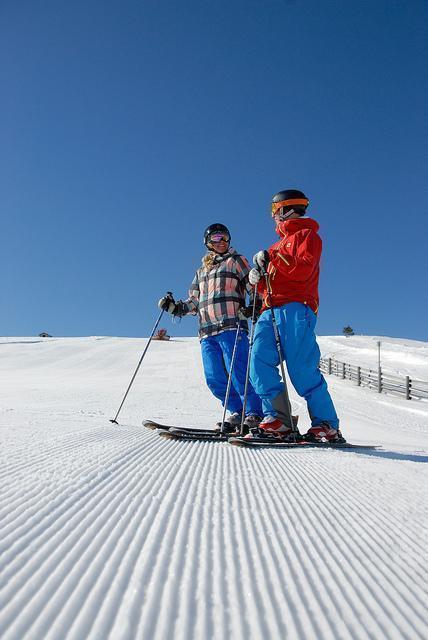Why are they so close together?
Answer the question by selecting the correct answer among the 4 following choices and explain your choice with a short sentence. The answer should be formatted with the following format: `Answer: choice
Rationale: rationale.`
Options: Curious, friendly, accidental, angry. Answer: friendly.
Rationale: They are at a stop and talking to each other 